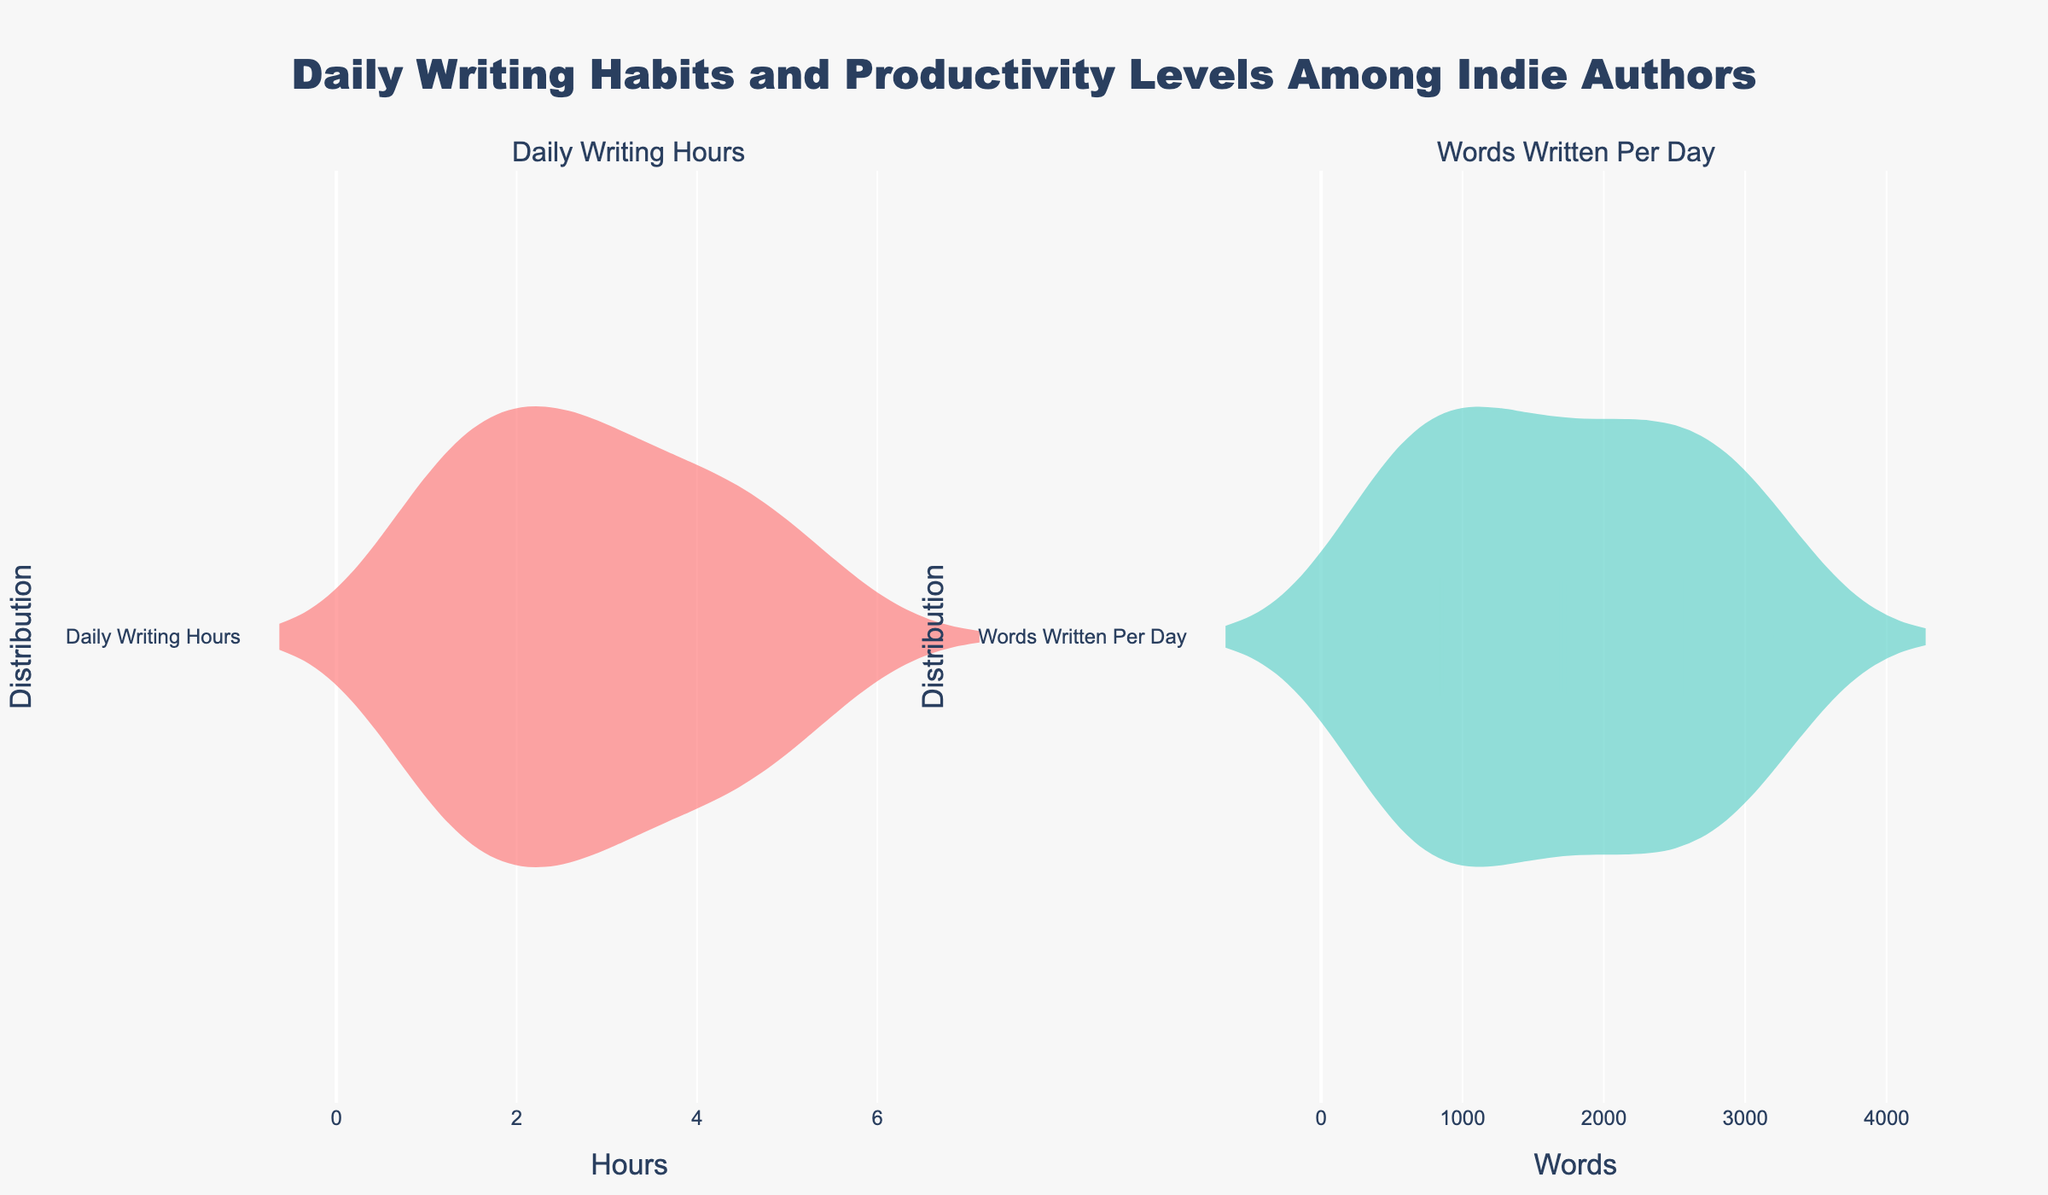What's the title of the figure? The title is positioned at the top center of the figure. Reading the text provided for the title gives us the information.
Answer: "Daily Writing Habits and Productivity Levels Among Indie Authors" What does the x-axis represent in the first plot? The x-axis of the first plot represents the variable being visualized. Examining the labels on the x-axis shows us that it is "Hours".
Answer: Daily Writing Hours What color represents Daily Writing Hours? The color used in the violin plot indicates Daily Writing Hours. From the color palette provided and the visual, this color can be identified.
Answer: Red Where do we see the densest concentration of Words Written Per Day? The densest concentration of points in a violin plot is represented by the widest part of the plot. Examining the second plot, the widest section appears around certain values.
Answer: Around 2000 words Which plot shows a higher maximum value, and what is it? Looking at the farthest right point in both violin plots can tell us which has a higher maximum value.
Answer: Words Written Per Day, around 3200 words Which author has the lowest Daily Writing Hours, and what is it? Since the question provides individual values by author, this can be determined by interpolating from the visual data and matching the data.
Answer: Donald Wright, 1 hour What's the median Daily Writing Hours? The median value is where 50% of the data lies below it in a distribution. It's visually indicated by the line inside the box plot overlay.
Answer: Around 3 hours Compare the variances of Daily Writing Hours vs Words Written Per Day. Which one seems higher? Variance is visually suggested by the width of the violin plots. A wider violin plot indicates higher variance. Comparing the shapes shows us the answer.
Answer: Words Written Per Day What is the interquartile range (IQR) for Words Written Per Day? The IQR is the range between the first quartile and the third quartile inside the box plot. The bounds inside the violin plot give this range.
Answer: From around 1250 to 2900 words Which metric has a more symmetrical distribution, Daily Writing Hours or Words Written Per Day? Symmetry in a violin plot is indicated by how even the two halves are around the center line. Visually comparing the two plots gives us the answer.
Answer: Daily Writing Hours 